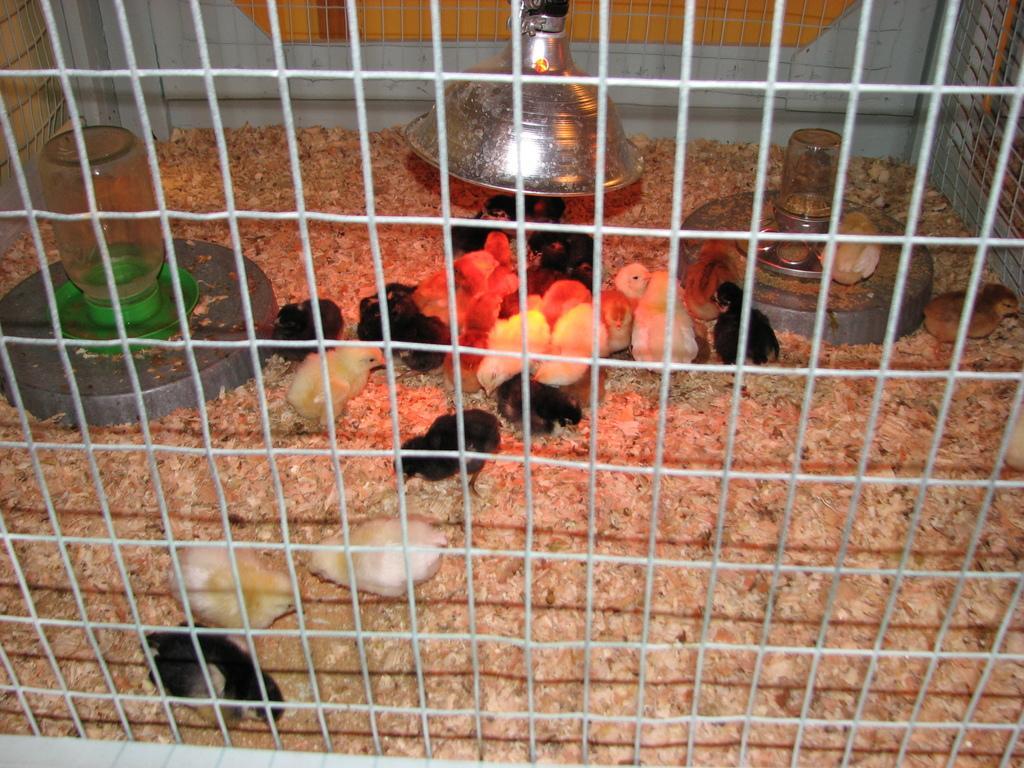How would you summarize this image in a sentence or two? In this image, we can see some chicks in a cage and there are some objects in the cage. 